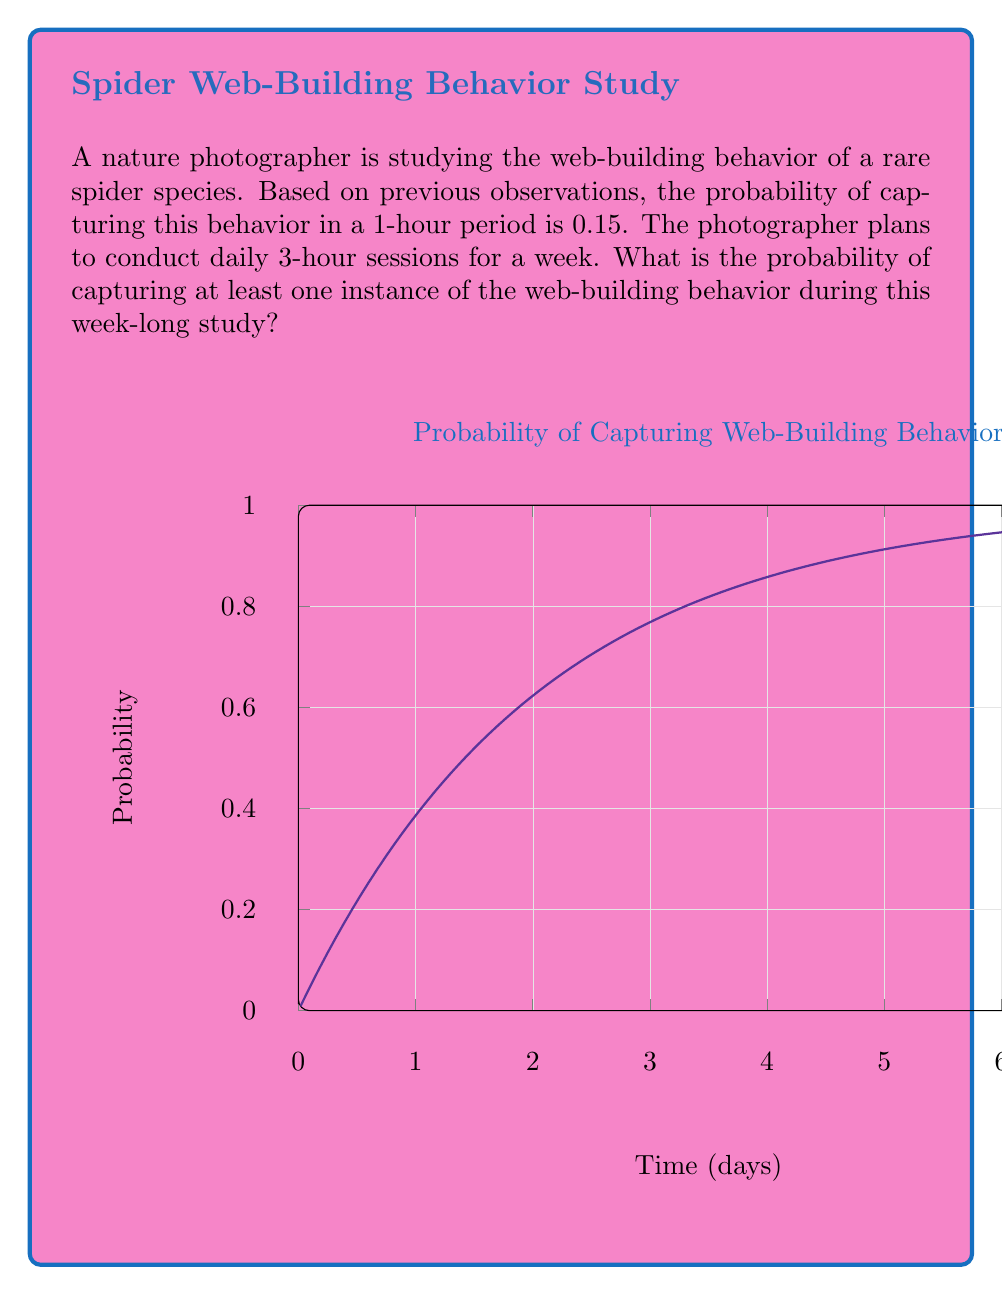Could you help me with this problem? Let's approach this step-by-step:

1) First, we need to calculate the probability of capturing the behavior in a 3-hour session:
   
   $$P(\text{capture in 3 hours}) = 1 - P(\text{no capture in 3 hours})$$
   $$= 1 - (1 - 0.15)^3 = 1 - 0.85^3 = 1 - 0.614125 = 0.385875$$

2) Now, we need to find the probability of capturing at least one instance in 7 days. This is equivalent to 1 minus the probability of not capturing any instance in 7 days:

   $$P(\text{at least one capture in 7 days}) = 1 - P(\text{no capture in 7 days})$$

3) The probability of no capture in 7 days is the probability of no capture in each day, raised to the power of 7:

   $$P(\text{no capture in 7 days}) = (1 - 0.385875)^7 = 0.614125^7 = 0.0002968$$

4) Therefore, the probability of at least one capture in 7 days is:

   $$P(\text{at least one capture in 7 days}) = 1 - 0.0002968 = 0.9997032$$

5) This can be rounded to 0.9997 or 99.97%.
Answer: 0.9997 